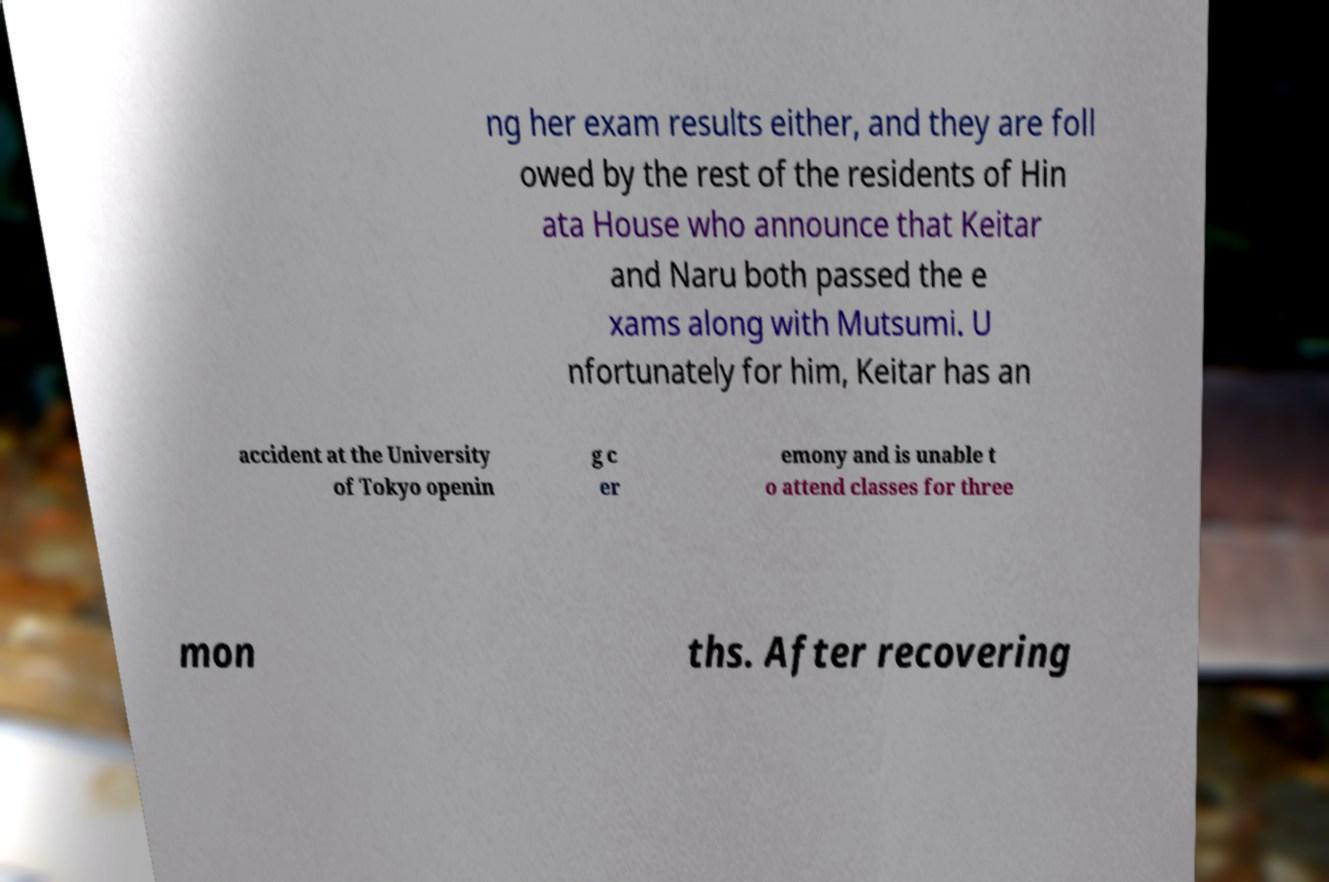For documentation purposes, I need the text within this image transcribed. Could you provide that? ng her exam results either, and they are foll owed by the rest of the residents of Hin ata House who announce that Keitar and Naru both passed the e xams along with Mutsumi. U nfortunately for him, Keitar has an accident at the University of Tokyo openin g c er emony and is unable t o attend classes for three mon ths. After recovering 